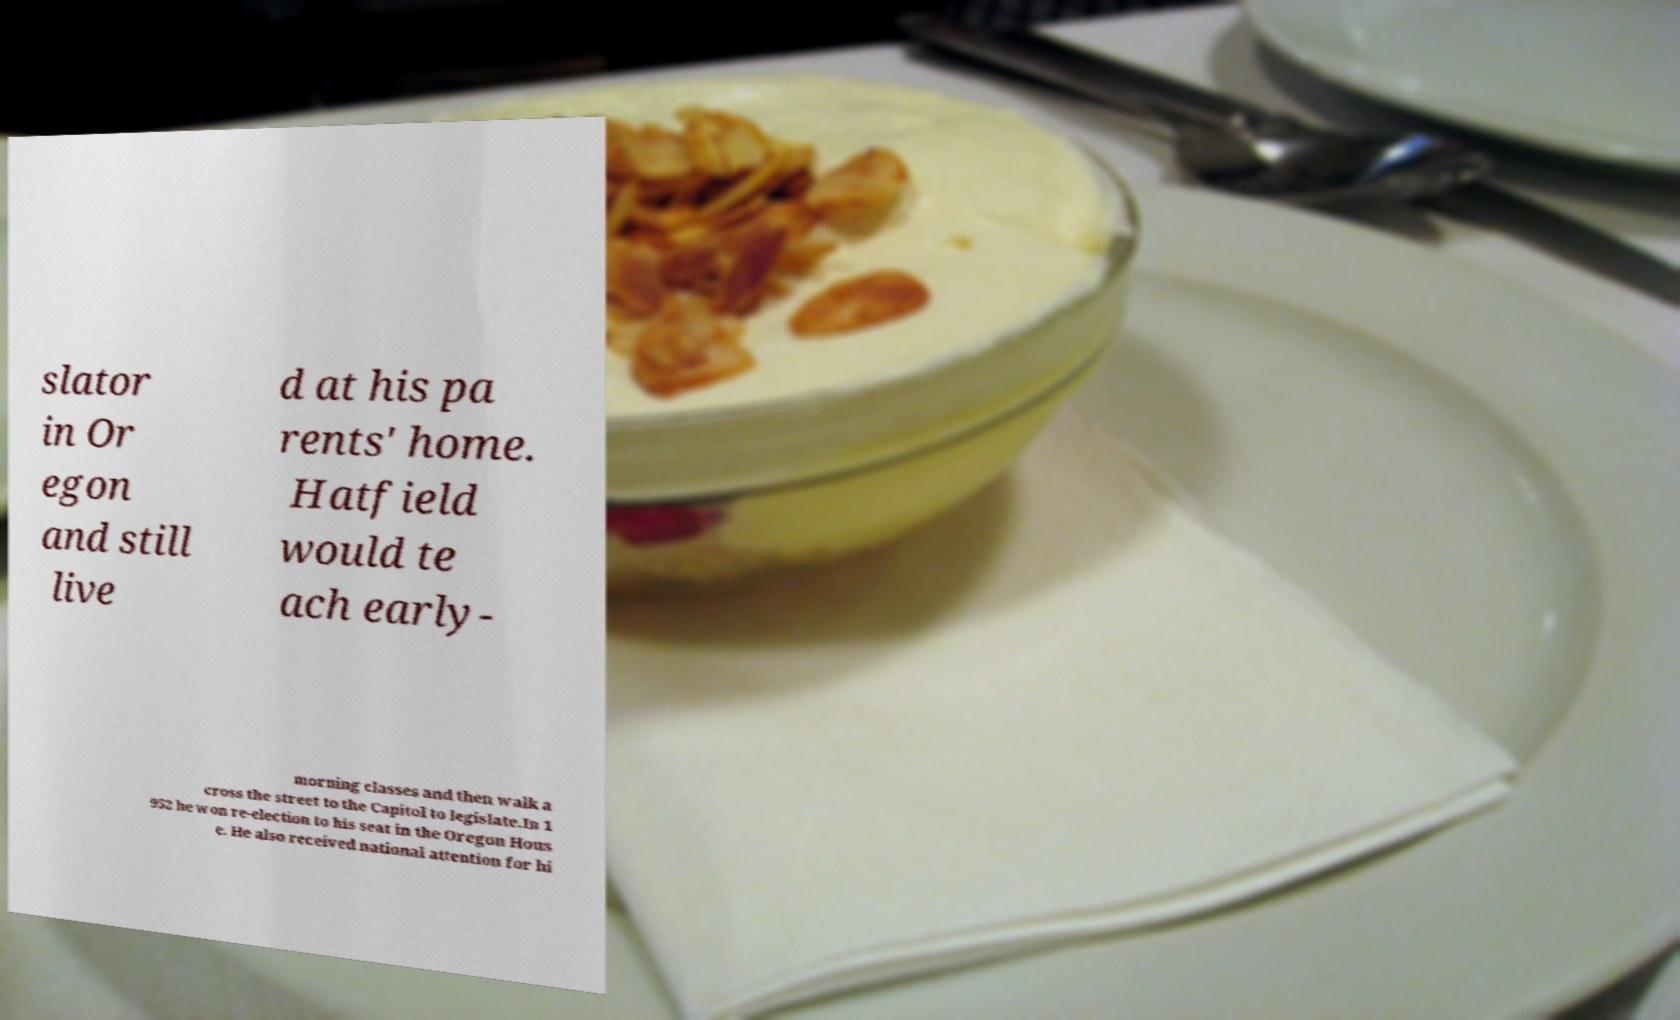There's text embedded in this image that I need extracted. Can you transcribe it verbatim? slator in Or egon and still live d at his pa rents' home. Hatfield would te ach early- morning classes and then walk a cross the street to the Capitol to legislate.In 1 952 he won re-election to his seat in the Oregon Hous e. He also received national attention for hi 